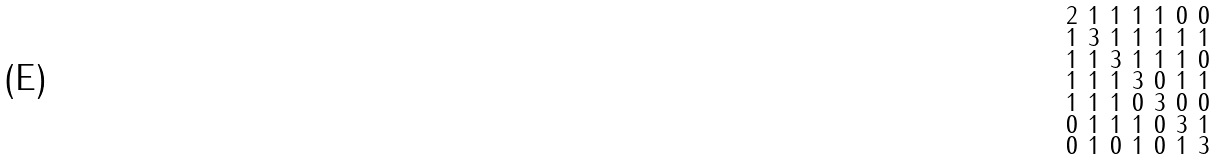<formula> <loc_0><loc_0><loc_500><loc_500>\begin{smallmatrix} 2 & 1 & 1 & 1 & 1 & 0 & 0 \\ 1 & 3 & 1 & 1 & 1 & 1 & 1 \\ 1 & 1 & 3 & 1 & 1 & 1 & 0 \\ 1 & 1 & 1 & 3 & 0 & 1 & 1 \\ 1 & 1 & 1 & 0 & 3 & 0 & 0 \\ 0 & 1 & 1 & 1 & 0 & 3 & 1 \\ 0 & 1 & 0 & 1 & 0 & 1 & 3 \end{smallmatrix}</formula> 